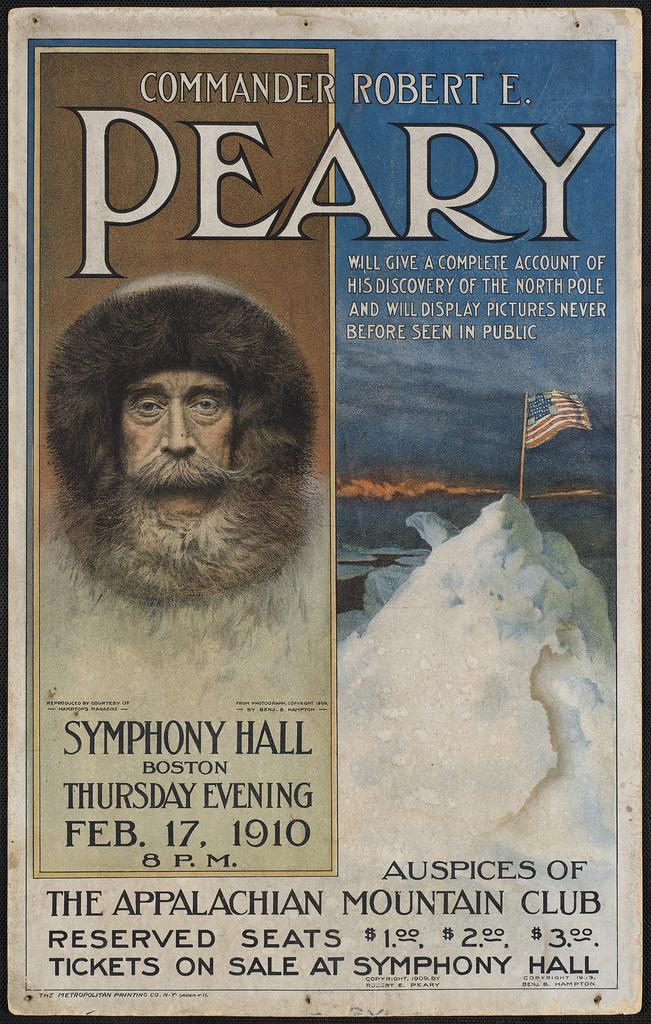What is featured on the poster in the image? The poster contains text. Can you describe the person in the image? There is a person in the image, but no specific details about their appearance or actions are provided. What is attached to the pole in the image? There is a flag on the pole in the image. How many eggs are visible in the image? There are no eggs present in the image. What type of animal can be seen interacting with the person in the image? There is no animal present in the image; only a person, a poster, and a pole with a flag are visible. 